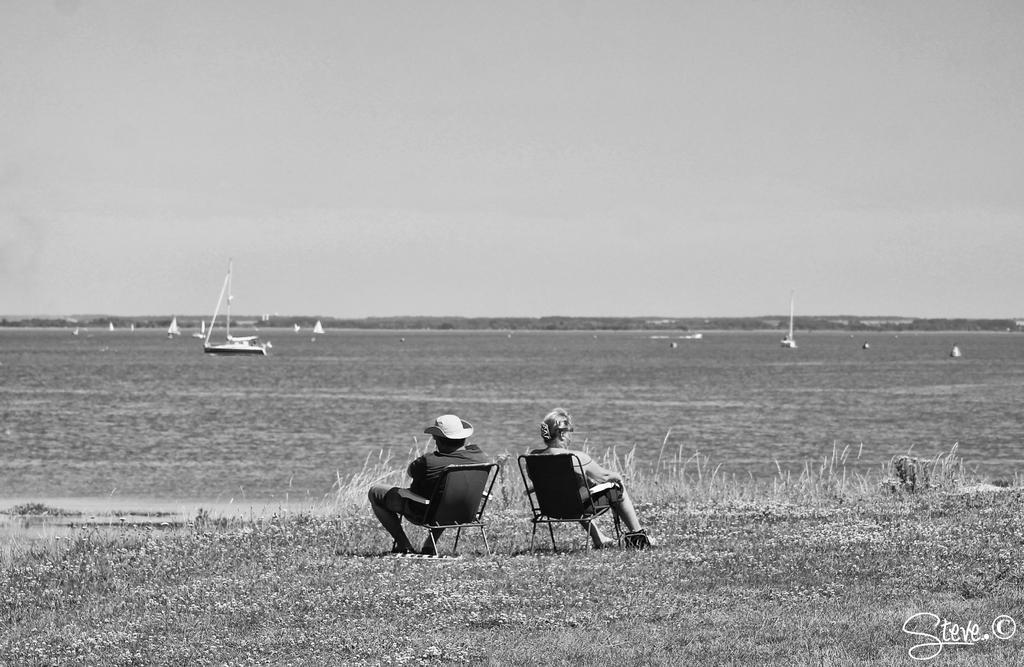Describe this image in one or two sentences. In this image there are two persons sitting on the chair in the bottom of this image and there is a grassy land in the bottom of this image and there is a sea in middle of this image and there are some boats are on this sea, and there is a sky on the top of this image. 